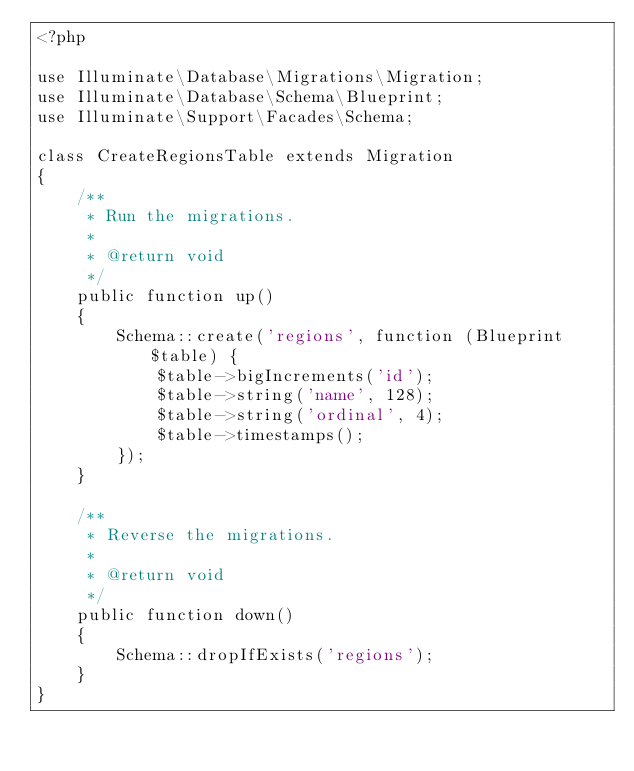<code> <loc_0><loc_0><loc_500><loc_500><_PHP_><?php

use Illuminate\Database\Migrations\Migration;
use Illuminate\Database\Schema\Blueprint;
use Illuminate\Support\Facades\Schema;

class CreateRegionsTable extends Migration
{
    /**
     * Run the migrations.
     *
     * @return void
     */
    public function up()
    {
        Schema::create('regions', function (Blueprint $table) {
            $table->bigIncrements('id');
            $table->string('name', 128);
            $table->string('ordinal', 4);
            $table->timestamps();
        });
    }

    /**
     * Reverse the migrations.
     *
     * @return void
     */
    public function down()
    {
        Schema::dropIfExists('regions');
    }
}
</code> 